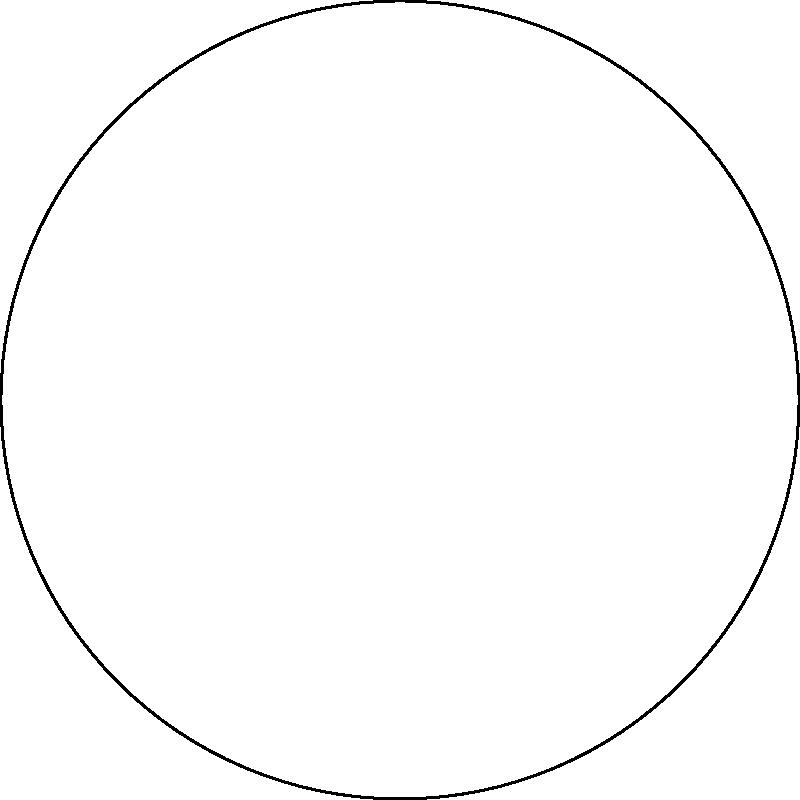A traditional Indian thali plate is arranged with 6 dishes numbered 1 to 6, placed at equal intervals around the circular plate. If the plate is rotated 120° clockwise, which dish will be in the position originally occupied by dish number 1? To solve this problem, let's follow these steps:

1. Understand the initial arrangement:
   - The thali plate is circular with 6 dishes arranged at equal intervals.
   - The dishes are numbered 1 to 6 in clockwise order.

2. Calculate the angle between each dish:
   - There are 6 dishes equally spaced around a circle (360°).
   - Angle between each dish = 360° ÷ 6 = 60°

3. Determine the effect of a 120° clockwise rotation:
   - 120° is equivalent to moving 2 positions clockwise (120° ÷ 60° = 2)

4. Find the new position of dish 1:
   - Dish 1 will move 2 positions clockwise.
   - The dish that was 2 positions counterclockwise from 1 will now occupy 1's original position.

5. Count 2 positions counterclockwise from 1:
   - Moving counterclockwise: 1 → 6 → 5

Therefore, after a 120° clockwise rotation, dish number 5 will be in the position originally occupied by dish number 1.
Answer: Dish number 5 